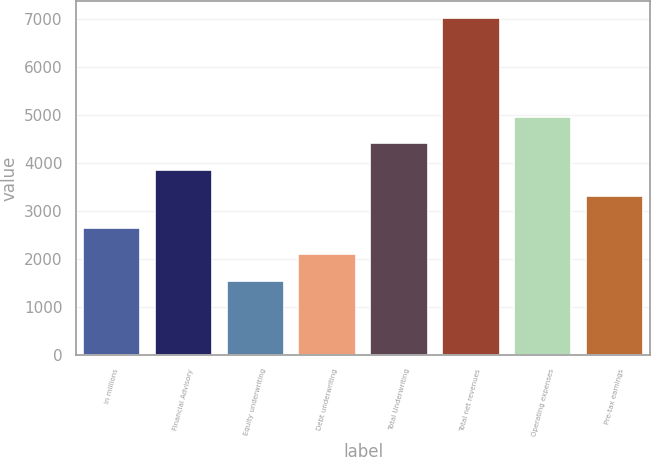Convert chart. <chart><loc_0><loc_0><loc_500><loc_500><bar_chart><fcel>in millions<fcel>Financial Advisory<fcel>Equity underwriting<fcel>Debt underwriting<fcel>Total Underwriting<fcel>Total net revenues<fcel>Operating expenses<fcel>Pre-tax earnings<nl><fcel>2642.2<fcel>3862.1<fcel>1546<fcel>2094.1<fcel>4410.2<fcel>7027<fcel>4958.3<fcel>3314<nl></chart> 